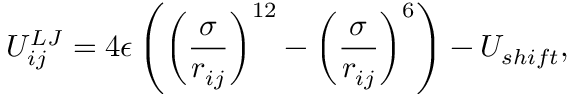<formula> <loc_0><loc_0><loc_500><loc_500>U _ { i j } ^ { L J } = 4 \epsilon \left ( \left ( \frac { \sigma } { r _ { i j } } \right ) ^ { 1 2 } - \left ( \frac { \sigma } { r _ { i j } } \right ) ^ { 6 } \right ) - U _ { s h i f t } ,</formula> 